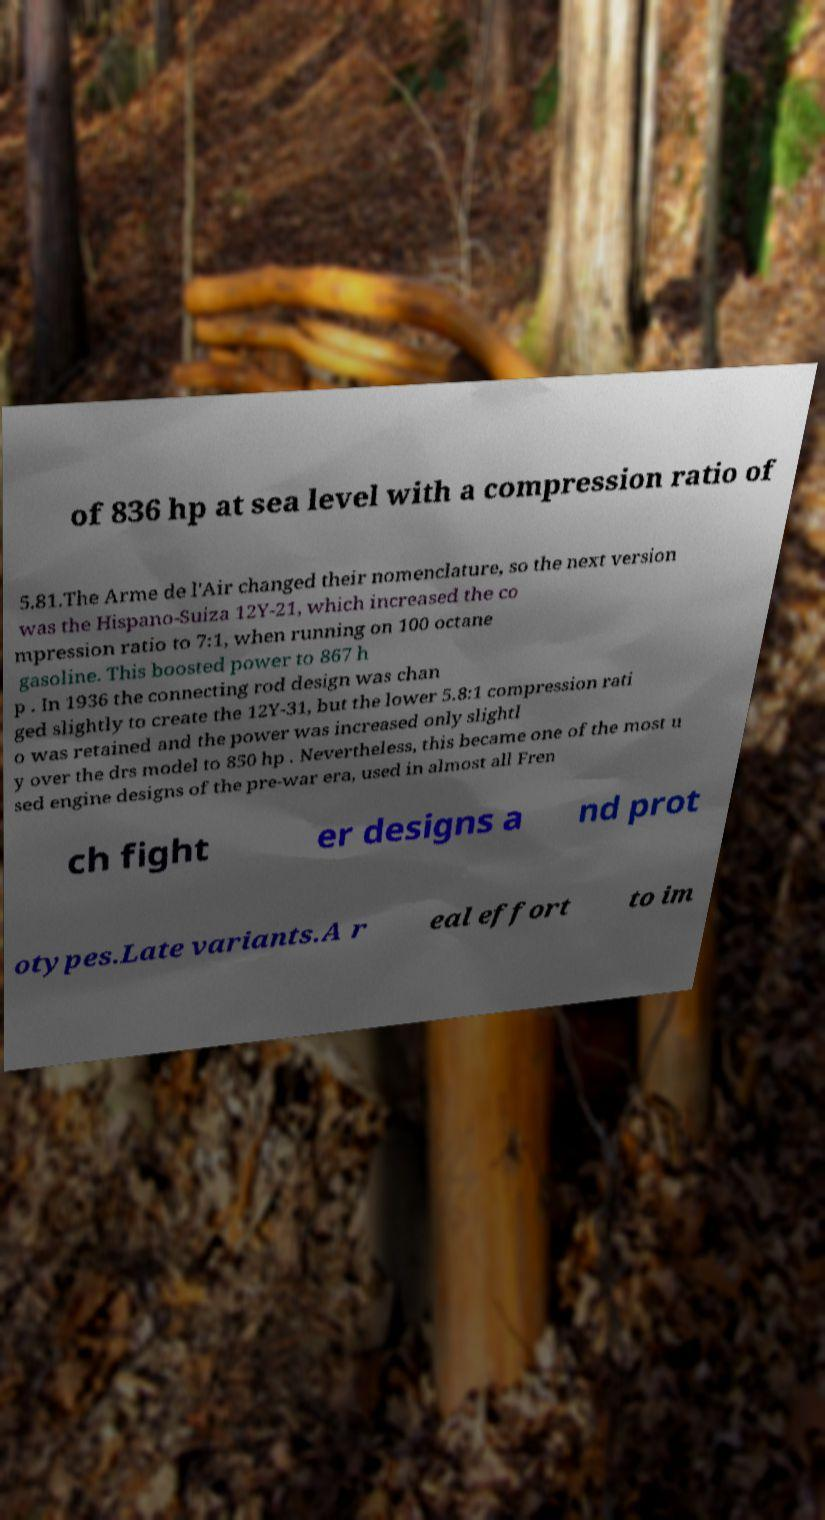Please read and relay the text visible in this image. What does it say? of 836 hp at sea level with a compression ratio of 5.81.The Arme de l'Air changed their nomenclature, so the next version was the Hispano-Suiza 12Y-21, which increased the co mpression ratio to 7:1, when running on 100 octane gasoline. This boosted power to 867 h p . In 1936 the connecting rod design was chan ged slightly to create the 12Y-31, but the lower 5.8:1 compression rati o was retained and the power was increased only slightl y over the drs model to 850 hp . Nevertheless, this became one of the most u sed engine designs of the pre-war era, used in almost all Fren ch fight er designs a nd prot otypes.Late variants.A r eal effort to im 